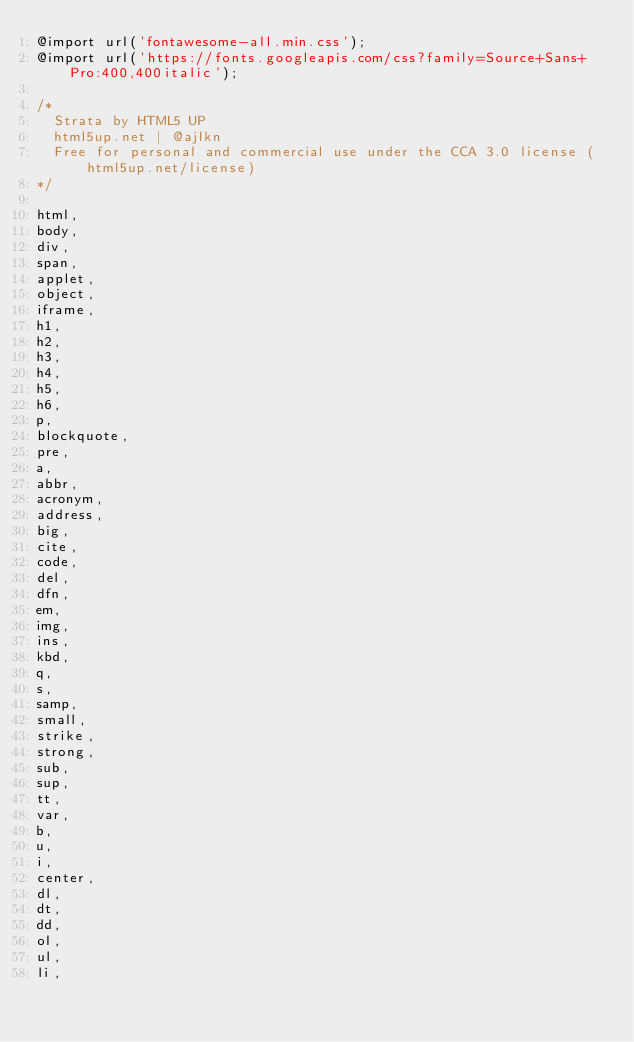<code> <loc_0><loc_0><loc_500><loc_500><_CSS_>@import url('fontawesome-all.min.css');
@import url('https://fonts.googleapis.com/css?family=Source+Sans+Pro:400,400italic');

/*
	Strata by HTML5 UP
	html5up.net | @ajlkn
	Free for personal and commercial use under the CCA 3.0 license (html5up.net/license)
*/

html,
body,
div,
span,
applet,
object,
iframe,
h1,
h2,
h3,
h4,
h5,
h6,
p,
blockquote,
pre,
a,
abbr,
acronym,
address,
big,
cite,
code,
del,
dfn,
em,
img,
ins,
kbd,
q,
s,
samp,
small,
strike,
strong,
sub,
sup,
tt,
var,
b,
u,
i,
center,
dl,
dt,
dd,
ol,
ul,
li,</code> 